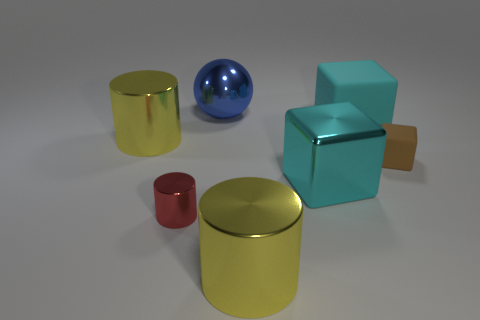Subtract all big metal cylinders. How many cylinders are left? 1 Add 1 cylinders. How many objects exist? 8 Subtract all brown cubes. How many cubes are left? 2 Subtract all gray cubes. How many yellow cylinders are left? 2 Subtract all spheres. How many objects are left? 6 Subtract 3 cylinders. How many cylinders are left? 0 Subtract all yellow cylinders. Subtract all cyan spheres. How many cylinders are left? 1 Subtract all cyan shiny blocks. Subtract all gray balls. How many objects are left? 6 Add 2 blue objects. How many blue objects are left? 3 Add 4 tiny green cubes. How many tiny green cubes exist? 4 